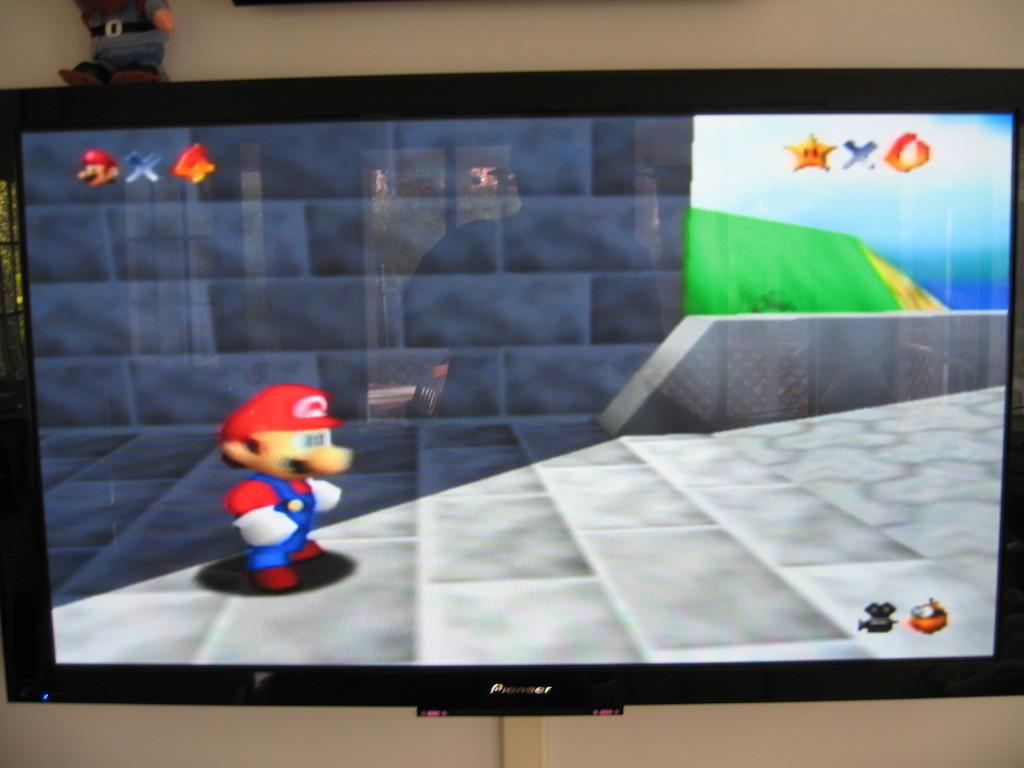What is the main object in the image? There is a screen in the image. What is being displayed on the screen? A video game is displayed on the screen. What type of quartz is used to create the screen in the image? The image does not provide information about the type of quartz used in the screen, and there is no indication that quartz is involved in the screen's construction. 